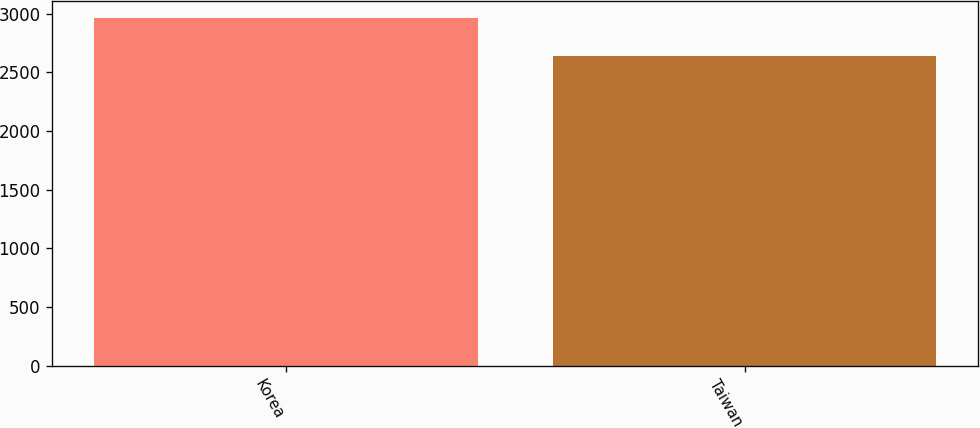Convert chart. <chart><loc_0><loc_0><loc_500><loc_500><bar_chart><fcel>Korea<fcel>Taiwan<nl><fcel>2962<fcel>2638<nl></chart> 